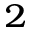<formula> <loc_0><loc_0><loc_500><loc_500>^ { 2 }</formula> 